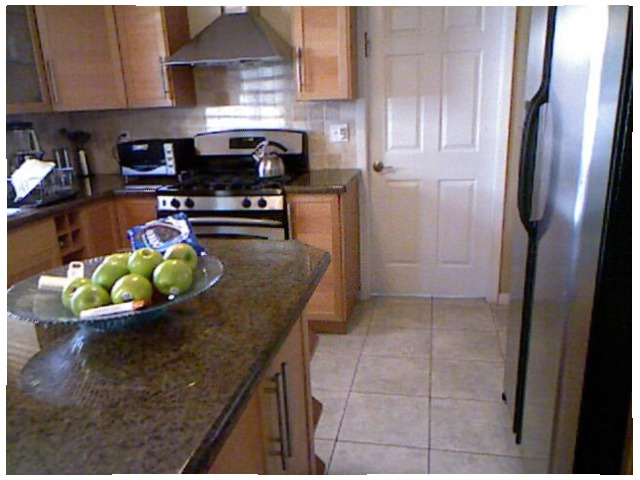<image>
Is there a apple on the stove? No. The apple is not positioned on the stove. They may be near each other, but the apple is not supported by or resting on top of the stove. Is the apples on the floor? No. The apples is not positioned on the floor. They may be near each other, but the apples is not supported by or resting on top of the floor. Is the green apple in the plate? Yes. The green apple is contained within or inside the plate, showing a containment relationship. Is the apple next to the bowl? No. The apple is not positioned next to the bowl. They are located in different areas of the scene. 